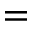Convert formula to latex. <formula><loc_0><loc_0><loc_500><loc_500>=</formula> 